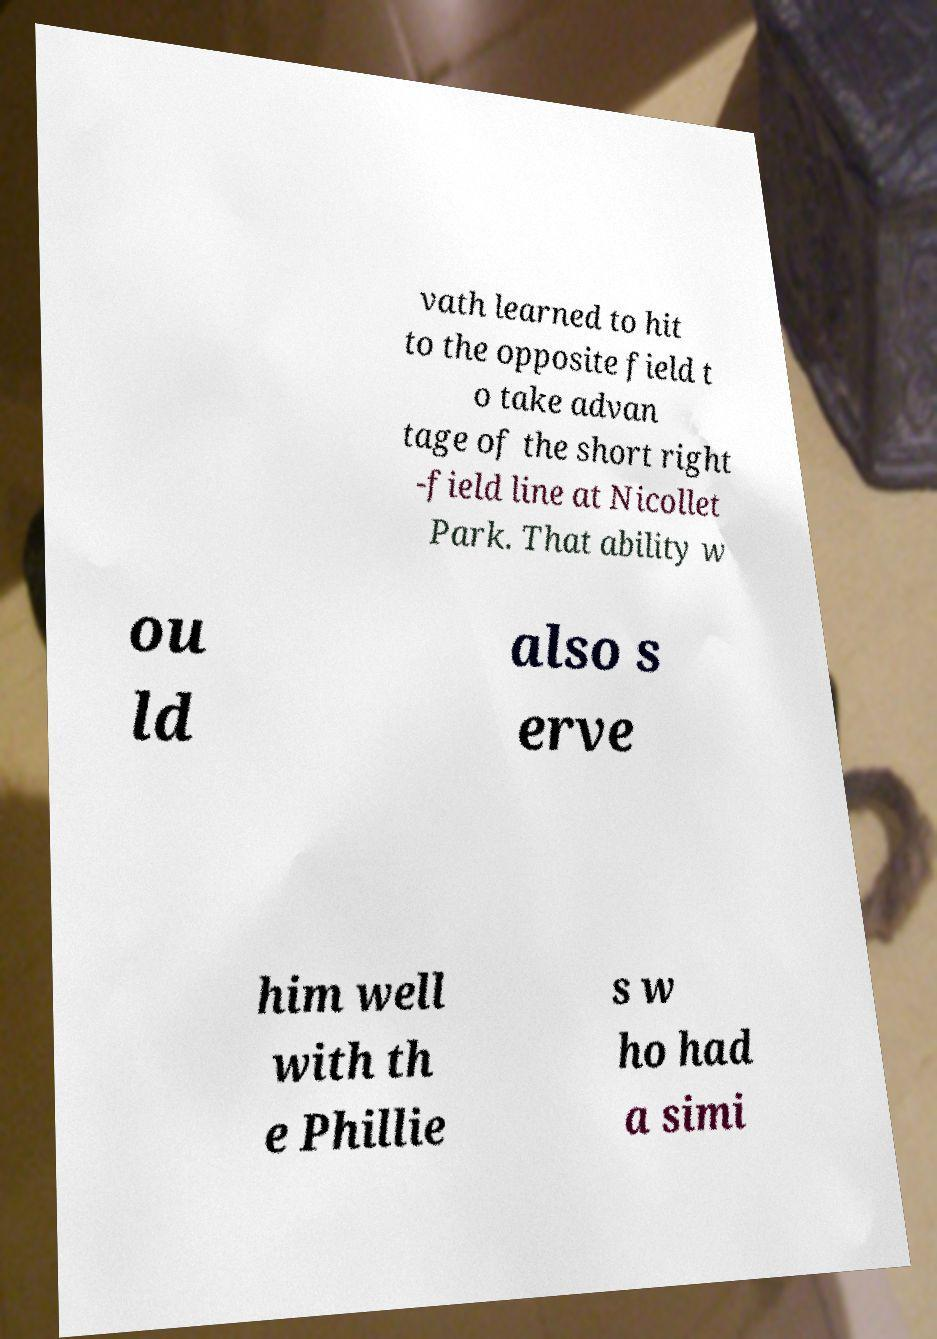Can you accurately transcribe the text from the provided image for me? vath learned to hit to the opposite field t o take advan tage of the short right -field line at Nicollet Park. That ability w ou ld also s erve him well with th e Phillie s w ho had a simi 